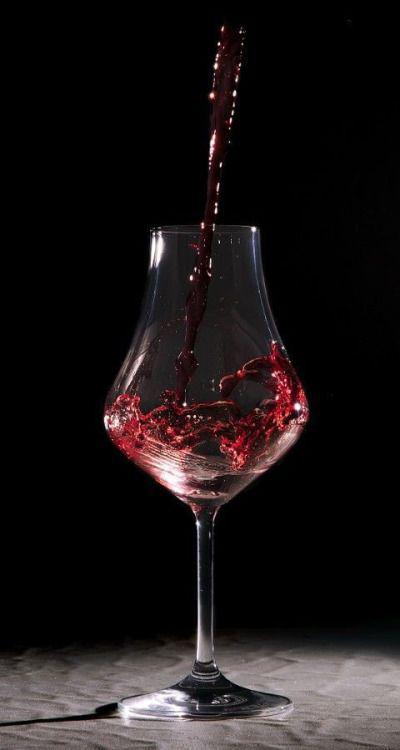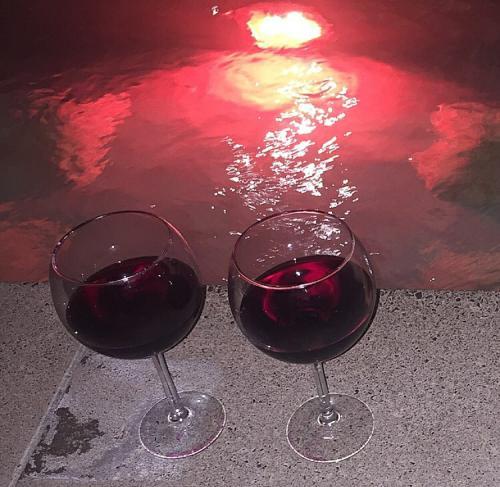The first image is the image on the left, the second image is the image on the right. Given the left and right images, does the statement "Wine is pouring from a bottle into a glass in the right image." hold true? Answer yes or no. No. 